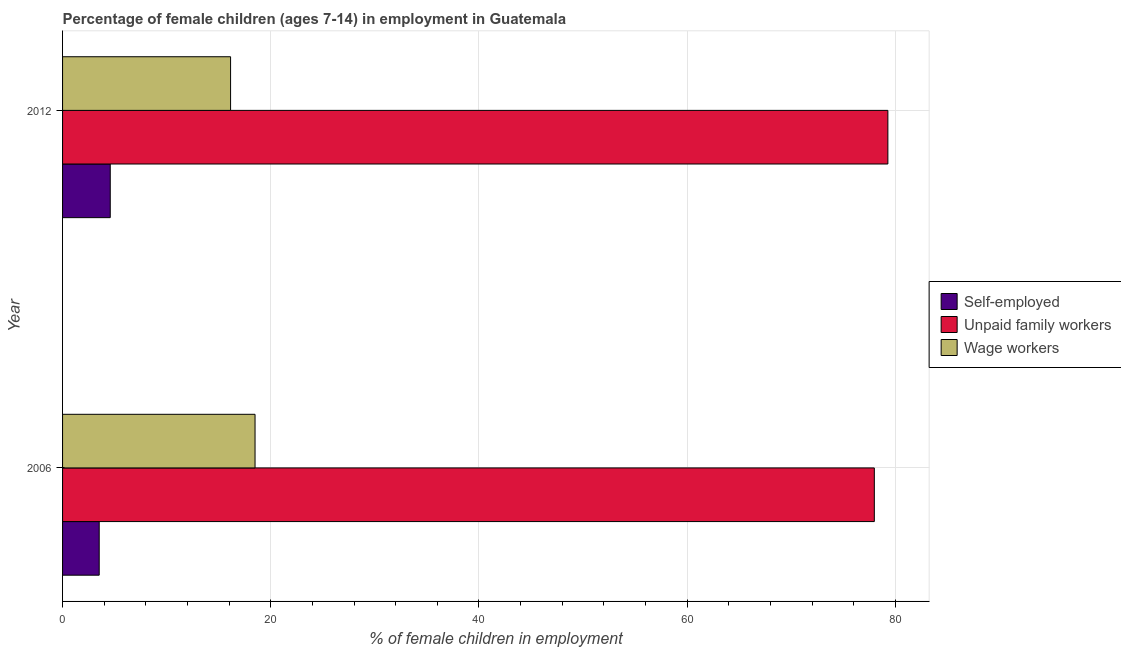How many groups of bars are there?
Your answer should be compact. 2. Are the number of bars per tick equal to the number of legend labels?
Give a very brief answer. Yes. How many bars are there on the 2nd tick from the top?
Provide a short and direct response. 3. How many bars are there on the 2nd tick from the bottom?
Your answer should be compact. 3. What is the percentage of self employed children in 2012?
Ensure brevity in your answer.  4.58. Across all years, what is the maximum percentage of children employed as wage workers?
Make the answer very short. 18.49. Across all years, what is the minimum percentage of children employed as wage workers?
Provide a succinct answer. 16.14. In which year was the percentage of children employed as unpaid family workers maximum?
Give a very brief answer. 2012. What is the total percentage of children employed as unpaid family workers in the graph?
Keep it short and to the point. 157.26. What is the difference between the percentage of children employed as wage workers in 2006 and that in 2012?
Provide a short and direct response. 2.35. What is the difference between the percentage of children employed as wage workers in 2006 and the percentage of self employed children in 2012?
Make the answer very short. 13.91. What is the average percentage of self employed children per year?
Provide a short and direct response. 4.05. In the year 2006, what is the difference between the percentage of self employed children and percentage of children employed as wage workers?
Your response must be concise. -14.97. What is the ratio of the percentage of self employed children in 2006 to that in 2012?
Make the answer very short. 0.77. Is the percentage of children employed as wage workers in 2006 less than that in 2012?
Ensure brevity in your answer.  No. Is the difference between the percentage of self employed children in 2006 and 2012 greater than the difference between the percentage of children employed as wage workers in 2006 and 2012?
Offer a terse response. No. What does the 2nd bar from the top in 2012 represents?
Give a very brief answer. Unpaid family workers. What does the 1st bar from the bottom in 2012 represents?
Provide a short and direct response. Self-employed. How many bars are there?
Keep it short and to the point. 6. How many years are there in the graph?
Your answer should be compact. 2. Are the values on the major ticks of X-axis written in scientific E-notation?
Your response must be concise. No. Does the graph contain any zero values?
Provide a short and direct response. No. Does the graph contain grids?
Keep it short and to the point. Yes. Where does the legend appear in the graph?
Offer a very short reply. Center right. How many legend labels are there?
Offer a very short reply. 3. What is the title of the graph?
Keep it short and to the point. Percentage of female children (ages 7-14) in employment in Guatemala. What is the label or title of the X-axis?
Ensure brevity in your answer.  % of female children in employment. What is the label or title of the Y-axis?
Provide a short and direct response. Year. What is the % of female children in employment of Self-employed in 2006?
Provide a succinct answer. 3.52. What is the % of female children in employment in Unpaid family workers in 2006?
Offer a terse response. 77.98. What is the % of female children in employment in Wage workers in 2006?
Your response must be concise. 18.49. What is the % of female children in employment of Self-employed in 2012?
Your answer should be very brief. 4.58. What is the % of female children in employment of Unpaid family workers in 2012?
Offer a terse response. 79.28. What is the % of female children in employment in Wage workers in 2012?
Offer a very short reply. 16.14. Across all years, what is the maximum % of female children in employment of Self-employed?
Provide a succinct answer. 4.58. Across all years, what is the maximum % of female children in employment of Unpaid family workers?
Offer a terse response. 79.28. Across all years, what is the maximum % of female children in employment of Wage workers?
Offer a very short reply. 18.49. Across all years, what is the minimum % of female children in employment of Self-employed?
Offer a terse response. 3.52. Across all years, what is the minimum % of female children in employment in Unpaid family workers?
Your answer should be very brief. 77.98. Across all years, what is the minimum % of female children in employment in Wage workers?
Provide a short and direct response. 16.14. What is the total % of female children in employment in Unpaid family workers in the graph?
Provide a succinct answer. 157.26. What is the total % of female children in employment in Wage workers in the graph?
Offer a terse response. 34.63. What is the difference between the % of female children in employment in Self-employed in 2006 and that in 2012?
Offer a terse response. -1.06. What is the difference between the % of female children in employment in Unpaid family workers in 2006 and that in 2012?
Provide a succinct answer. -1.3. What is the difference between the % of female children in employment in Wage workers in 2006 and that in 2012?
Give a very brief answer. 2.35. What is the difference between the % of female children in employment in Self-employed in 2006 and the % of female children in employment in Unpaid family workers in 2012?
Offer a terse response. -75.76. What is the difference between the % of female children in employment in Self-employed in 2006 and the % of female children in employment in Wage workers in 2012?
Make the answer very short. -12.62. What is the difference between the % of female children in employment in Unpaid family workers in 2006 and the % of female children in employment in Wage workers in 2012?
Provide a short and direct response. 61.84. What is the average % of female children in employment in Self-employed per year?
Offer a very short reply. 4.05. What is the average % of female children in employment in Unpaid family workers per year?
Your answer should be very brief. 78.63. What is the average % of female children in employment in Wage workers per year?
Keep it short and to the point. 17.32. In the year 2006, what is the difference between the % of female children in employment of Self-employed and % of female children in employment of Unpaid family workers?
Your answer should be very brief. -74.46. In the year 2006, what is the difference between the % of female children in employment of Self-employed and % of female children in employment of Wage workers?
Make the answer very short. -14.97. In the year 2006, what is the difference between the % of female children in employment of Unpaid family workers and % of female children in employment of Wage workers?
Your answer should be compact. 59.49. In the year 2012, what is the difference between the % of female children in employment in Self-employed and % of female children in employment in Unpaid family workers?
Your answer should be very brief. -74.7. In the year 2012, what is the difference between the % of female children in employment in Self-employed and % of female children in employment in Wage workers?
Ensure brevity in your answer.  -11.56. In the year 2012, what is the difference between the % of female children in employment in Unpaid family workers and % of female children in employment in Wage workers?
Offer a very short reply. 63.14. What is the ratio of the % of female children in employment of Self-employed in 2006 to that in 2012?
Ensure brevity in your answer.  0.77. What is the ratio of the % of female children in employment in Unpaid family workers in 2006 to that in 2012?
Provide a short and direct response. 0.98. What is the ratio of the % of female children in employment in Wage workers in 2006 to that in 2012?
Your answer should be very brief. 1.15. What is the difference between the highest and the second highest % of female children in employment of Self-employed?
Ensure brevity in your answer.  1.06. What is the difference between the highest and the second highest % of female children in employment of Wage workers?
Offer a very short reply. 2.35. What is the difference between the highest and the lowest % of female children in employment in Self-employed?
Offer a terse response. 1.06. What is the difference between the highest and the lowest % of female children in employment in Wage workers?
Offer a very short reply. 2.35. 